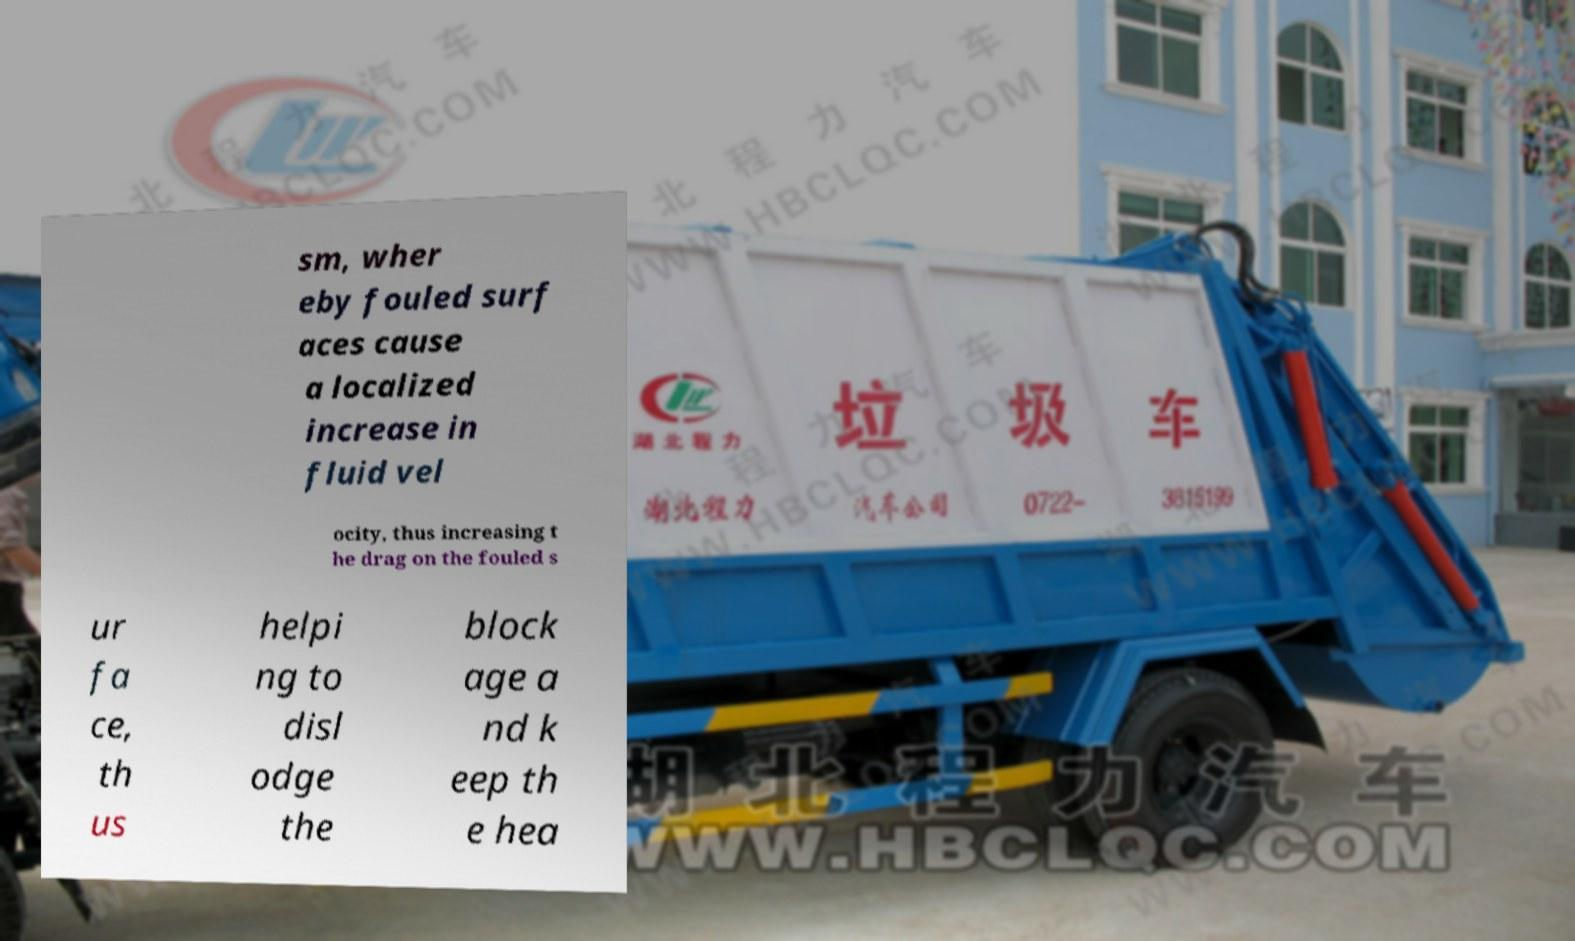For documentation purposes, I need the text within this image transcribed. Could you provide that? sm, wher eby fouled surf aces cause a localized increase in fluid vel ocity, thus increasing t he drag on the fouled s ur fa ce, th us helpi ng to disl odge the block age a nd k eep th e hea 